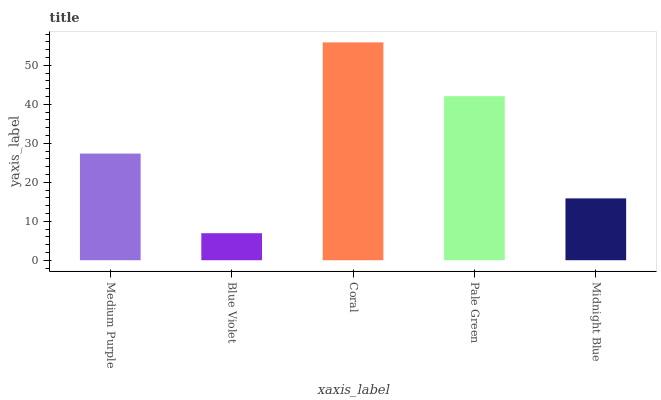Is Blue Violet the minimum?
Answer yes or no. Yes. Is Coral the maximum?
Answer yes or no. Yes. Is Coral the minimum?
Answer yes or no. No. Is Blue Violet the maximum?
Answer yes or no. No. Is Coral greater than Blue Violet?
Answer yes or no. Yes. Is Blue Violet less than Coral?
Answer yes or no. Yes. Is Blue Violet greater than Coral?
Answer yes or no. No. Is Coral less than Blue Violet?
Answer yes or no. No. Is Medium Purple the high median?
Answer yes or no. Yes. Is Medium Purple the low median?
Answer yes or no. Yes. Is Blue Violet the high median?
Answer yes or no. No. Is Blue Violet the low median?
Answer yes or no. No. 